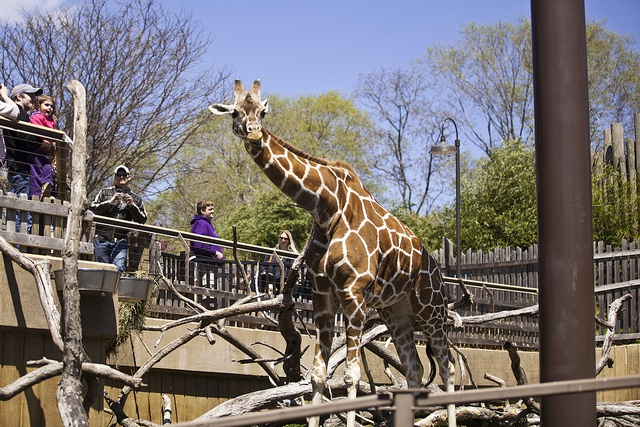Describe the objects in this image and their specific colors. I can see giraffe in lavender, black, ivory, gray, and maroon tones, people in lavender, black, gray, darkgray, and white tones, people in lavender, black, gray, maroon, and purple tones, people in lavender, black, purple, and navy tones, and people in lavender, white, gray, darkgray, and black tones in this image. 